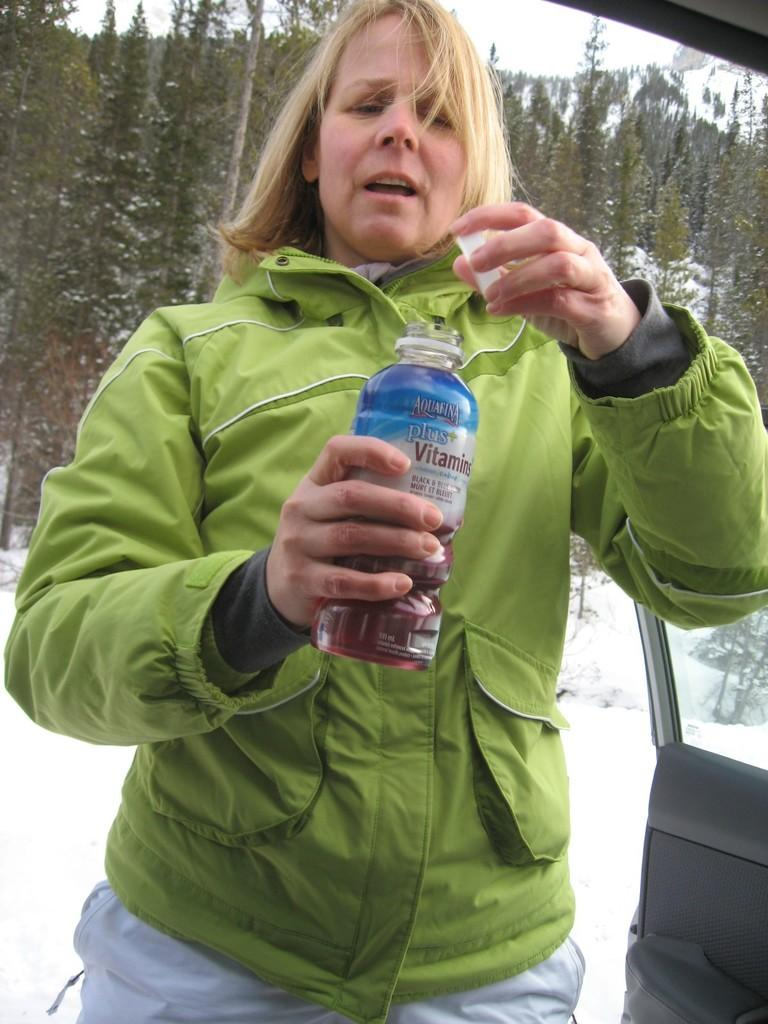Who is present in the image? There is a woman in the image. What is the woman holding in the image? The woman is holding a bottle. What can be seen in the background of the image? There is snow and trees in the background of the image. How many cacti are visible in the image? There are no cacti present in the image. What are the girls doing in the image? There are no girls present in the image; only a woman is visible. 